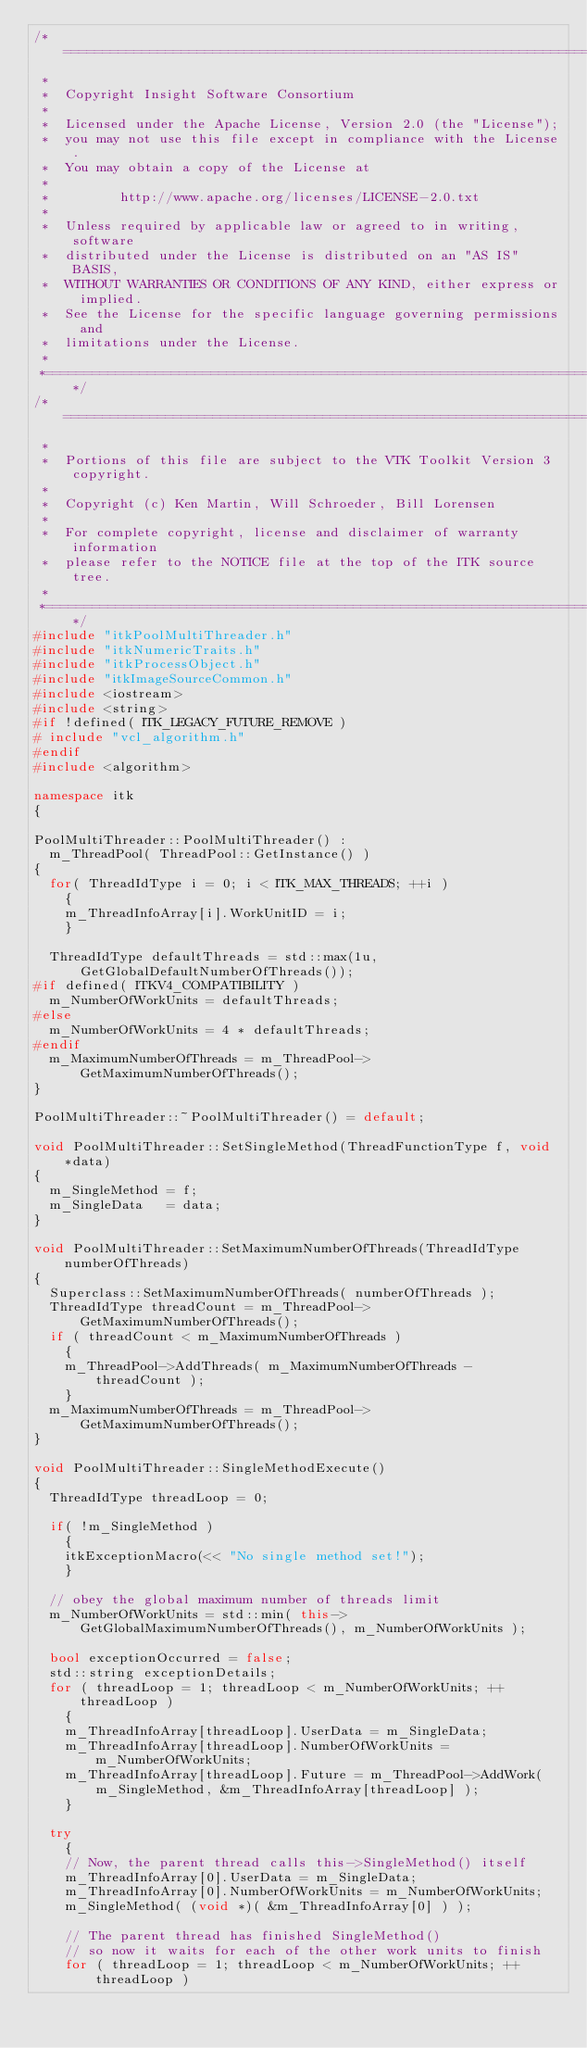Convert code to text. <code><loc_0><loc_0><loc_500><loc_500><_C++_>/*=========================================================================
 *
 *  Copyright Insight Software Consortium
 *
 *  Licensed under the Apache License, Version 2.0 (the "License");
 *  you may not use this file except in compliance with the License.
 *  You may obtain a copy of the License at
 *
 *         http://www.apache.org/licenses/LICENSE-2.0.txt
 *
 *  Unless required by applicable law or agreed to in writing, software
 *  distributed under the License is distributed on an "AS IS" BASIS,
 *  WITHOUT WARRANTIES OR CONDITIONS OF ANY KIND, either express or implied.
 *  See the License for the specific language governing permissions and
 *  limitations under the License.
 *
 *=========================================================================*/
/*=========================================================================
 *
 *  Portions of this file are subject to the VTK Toolkit Version 3 copyright.
 *
 *  Copyright (c) Ken Martin, Will Schroeder, Bill Lorensen
 *
 *  For complete copyright, license and disclaimer of warranty information
 *  please refer to the NOTICE file at the top of the ITK source tree.
 *
 *=========================================================================*/
#include "itkPoolMultiThreader.h"
#include "itkNumericTraits.h"
#include "itkProcessObject.h"
#include "itkImageSourceCommon.h"
#include <iostream>
#include <string>
#if !defined( ITK_LEGACY_FUTURE_REMOVE )
# include "vcl_algorithm.h"
#endif
#include <algorithm>

namespace itk
{

PoolMultiThreader::PoolMultiThreader() :
  m_ThreadPool( ThreadPool::GetInstance() )
{
  for( ThreadIdType i = 0; i < ITK_MAX_THREADS; ++i )
    {
    m_ThreadInfoArray[i].WorkUnitID = i;
    }

  ThreadIdType defaultThreads = std::max(1u, GetGlobalDefaultNumberOfThreads());
#if defined( ITKV4_COMPATIBILITY )
  m_NumberOfWorkUnits = defaultThreads;
#else
  m_NumberOfWorkUnits = 4 * defaultThreads;
#endif
  m_MaximumNumberOfThreads = m_ThreadPool->GetMaximumNumberOfThreads();
}

PoolMultiThreader::~PoolMultiThreader() = default;

void PoolMultiThreader::SetSingleMethod(ThreadFunctionType f, void *data)
{
  m_SingleMethod = f;
  m_SingleData   = data;
}

void PoolMultiThreader::SetMaximumNumberOfThreads(ThreadIdType numberOfThreads)
{
  Superclass::SetMaximumNumberOfThreads( numberOfThreads );
  ThreadIdType threadCount = m_ThreadPool->GetMaximumNumberOfThreads();
  if ( threadCount < m_MaximumNumberOfThreads )
    {
    m_ThreadPool->AddThreads( m_MaximumNumberOfThreads - threadCount );
    }
  m_MaximumNumberOfThreads = m_ThreadPool->GetMaximumNumberOfThreads();
}

void PoolMultiThreader::SingleMethodExecute()
{
  ThreadIdType threadLoop = 0;

  if( !m_SingleMethod )
    {
    itkExceptionMacro(<< "No single method set!");
    }

  // obey the global maximum number of threads limit
  m_NumberOfWorkUnits = std::min( this->GetGlobalMaximumNumberOfThreads(), m_NumberOfWorkUnits );

  bool exceptionOccurred = false;
  std::string exceptionDetails;
  for ( threadLoop = 1; threadLoop < m_NumberOfWorkUnits; ++threadLoop )
    {
    m_ThreadInfoArray[threadLoop].UserData = m_SingleData;
    m_ThreadInfoArray[threadLoop].NumberOfWorkUnits = m_NumberOfWorkUnits;
    m_ThreadInfoArray[threadLoop].Future = m_ThreadPool->AddWork( m_SingleMethod, &m_ThreadInfoArray[threadLoop] );
    }

  try
    {
    // Now, the parent thread calls this->SingleMethod() itself
    m_ThreadInfoArray[0].UserData = m_SingleData;
    m_ThreadInfoArray[0].NumberOfWorkUnits = m_NumberOfWorkUnits;
    m_SingleMethod( (void *)( &m_ThreadInfoArray[0] ) );

    // The parent thread has finished SingleMethod()
    // so now it waits for each of the other work units to finish
    for ( threadLoop = 1; threadLoop < m_NumberOfWorkUnits; ++threadLoop )</code> 